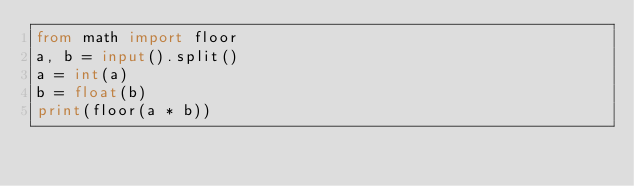<code> <loc_0><loc_0><loc_500><loc_500><_Python_>from math import floor
a, b = input().split()
a = int(a)
b = float(b)
print(floor(a * b))</code> 